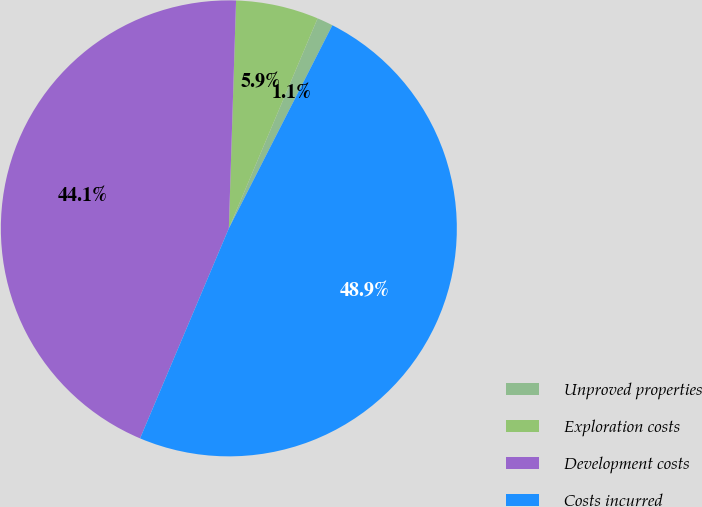<chart> <loc_0><loc_0><loc_500><loc_500><pie_chart><fcel>Unproved properties<fcel>Exploration costs<fcel>Development costs<fcel>Costs incurred<nl><fcel>1.14%<fcel>5.86%<fcel>44.14%<fcel>48.86%<nl></chart> 